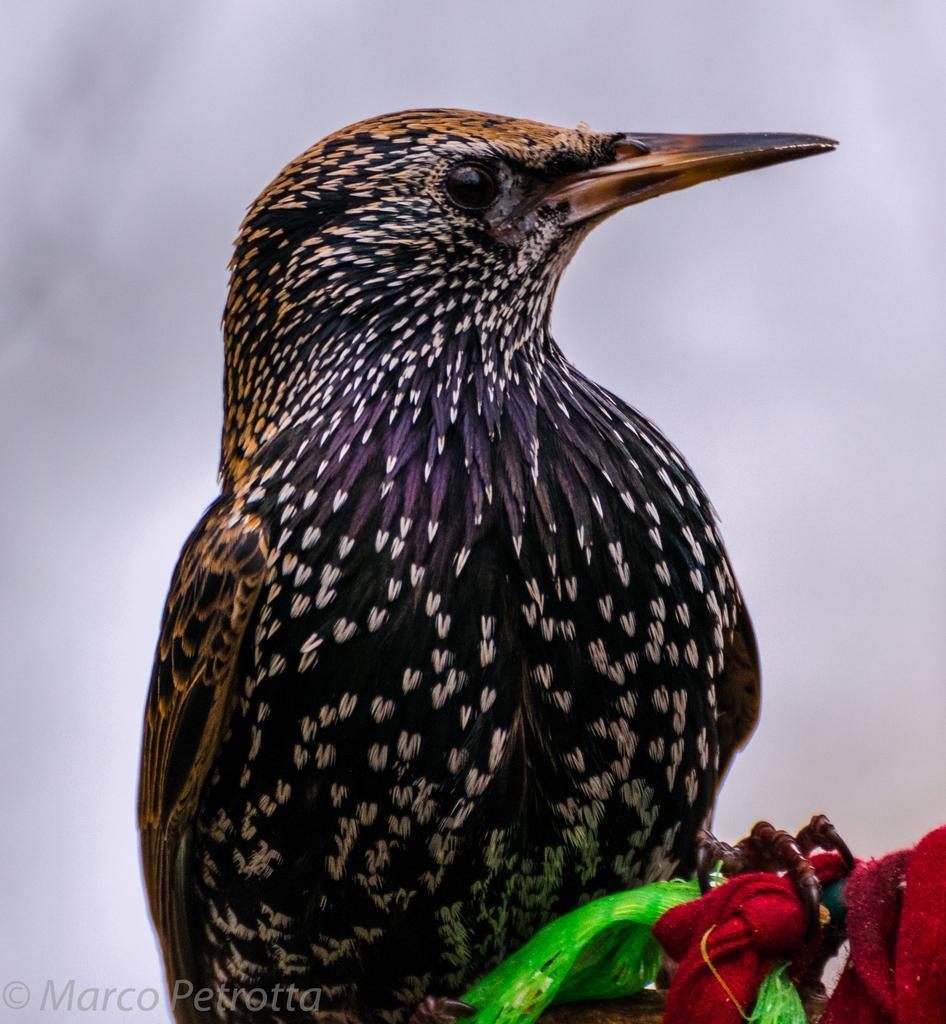How would you summarize this image in a sentence or two? In this picture we can see a bird in the front, at the right bottom there are ribbons, we can see the sky in the background, at the left bottom we can see some text. 